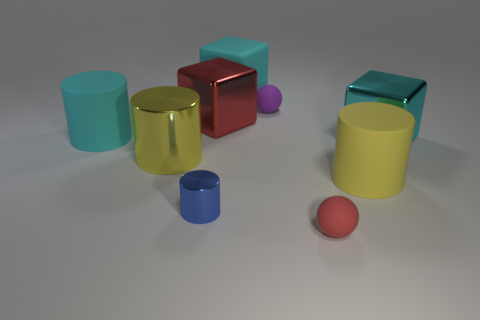What number of green rubber things are there?
Your answer should be very brief. 0. There is a yellow shiny object; is it the same shape as the cyan rubber thing on the left side of the big yellow metal thing?
Offer a very short reply. Yes. There is a purple sphere left of the red matte sphere; how big is it?
Your response must be concise. Small. What is the material of the big red cube?
Give a very brief answer. Metal. Is the shape of the large yellow object on the left side of the large red block the same as  the small metallic object?
Ensure brevity in your answer.  Yes. What is the size of the other block that is the same color as the rubber block?
Give a very brief answer. Large. Are there any yellow cubes of the same size as the cyan rubber cylinder?
Provide a succinct answer. No. There is a small rubber thing that is behind the cyan rubber thing that is left of the tiny metallic cylinder; is there a small rubber ball that is on the left side of it?
Your answer should be very brief. No. Do the small metal cylinder and the small matte sphere behind the small blue shiny object have the same color?
Your answer should be very brief. No. There is a cylinder that is in front of the yellow cylinder that is right of the big rubber thing behind the purple sphere; what is it made of?
Provide a succinct answer. Metal. 